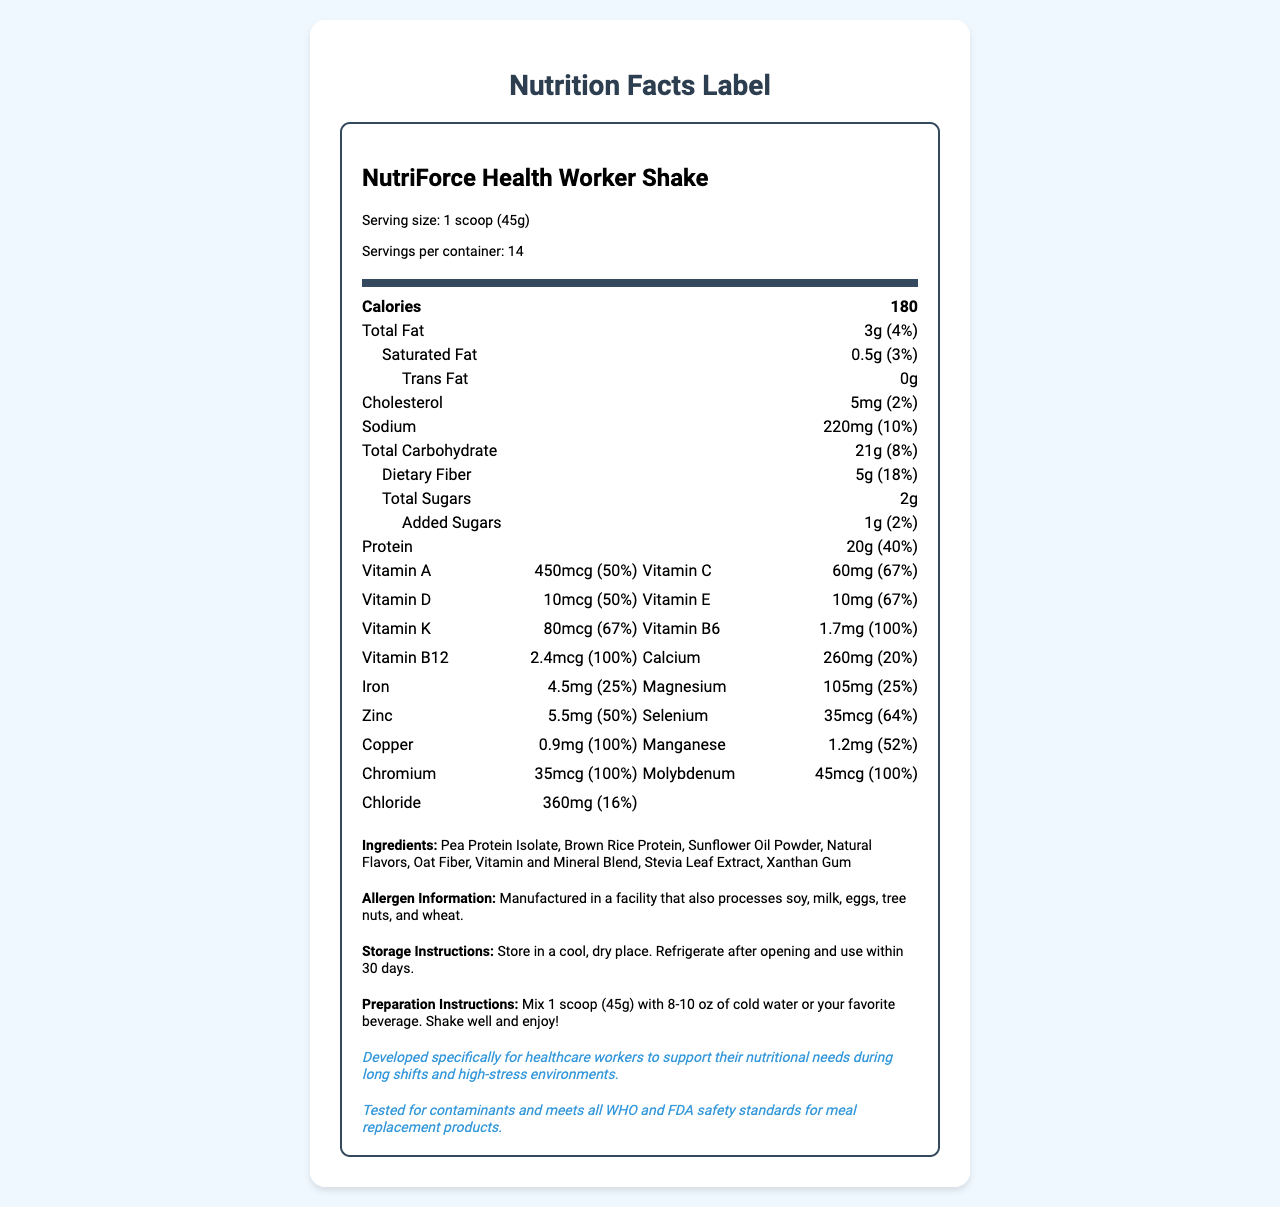what is the serving size of NutriForce Health Worker Shake? The serving size is listed as 1 scoop (45g) in the serving information section.
Answer: 1 scoop (45g) how many servings are there per container? The document specifies that there are 14 servings per container.
Answer: 14 what is the amount of dietary fiber per serving? Under the total carbohydrate section, it indicates that there are 5 grams of dietary fiber per serving.
Answer: 5g what is the daily value percentage of vitamin C in the shake? The document shows that the daily value percentage for vitamin C is 67%.
Answer: 67% how much protein does each serving contain? The protein content per serving is listed as 20 grams.
Answer: 20g which ingredient is a natural sweetener used in the shake? A. Sucralose B. Stevia Leaf Extract C. Aspartame D. High Fructose Corn Syrup The ingredient list includes Stevia Leaf Extract as a natural sweetener.
Answer: B how much vitamin D does one serving provide? The amount of vitamin D per serving is shown as 10 micrograms.
Answer: 10mcg is there any trans fat in the shake? It is stated that there are 0 grams of trans fat in the shake.
Answer: No which mineral has the highest daily value percentage? A. Calcium B. Iron C. Magnesium D. Selenium Selenium has a daily value percentage of 64%, which is the highest among the listed minerals.
Answer: D describe the purpose of NutriForce Health Worker Shake. The document contains a specific section stating that the shake is developed to support the nutritional needs of healthcare workers during long shifts and high-stress situations.
Answer: It is developed specifically for healthcare workers to support their nutritional needs during long shifts and high-stress environments. how long should you consume the product after opening it? The storage instructions advise refrigerating after opening and using the product within 30 days.
Answer: Store in a cool, dry place. Refrigerate after opening and use within 30 days. is this product suitable for individuals with nut allergies? The allergen information notes that the product is manufactured in a facility that processes tree nuts, but it is unclear if the shake itself directly contains nuts.
Answer: Cannot be determined what is the total percentage of daily value for iron in each serving? The document indicates that the shake provides 25% of the daily value for iron per serving.
Answer: 25% what are the first three ingredients in the shake? The ingredients section lists Pea Protein Isolate, Brown Rice Protein, and Sunflower Oil Powder as the first three components.
Answer: Pea Protein Isolate, Brown Rice Protein, Sunflower Oil Powder does the shake contain any added sugars? The shake contains 1 gram of added sugars as specified in the document.
Answer: Yes which vitamins are provided at 100% of daily value per serving? The document lists these vitamins as each providing 100% of the daily value per serving.
Answer: Thiamin, Riboflavin, Niacin, Vitamin B6, Folate, Vitamin B12, Biotin, Pantothenic Acid, Chromium, Molybdenum summarize the preparation instructions for the shake. The preparation instructions are straightforward: mix one scoop of the powder with 8-10 ounces of cold water or a preferred beverage, shake well, and enjoy.
Answer: Mix 1 scoop (45g) with 8-10 oz of cold water or your favorite beverage. Shake well and enjoy! how many grams of total carbohydrates are there per serving? The total carbohydrate content per serving is listed as 21 grams.
Answer: 21g what is the main purpose of including a "quality assurance" statement in the document? The quality assurance statement is included to reassure consumers about the safety and compliance of the product with established health standards.
Answer: To assure consumers that the product is tested for contaminants and meets WHO and FDA safety standards. 